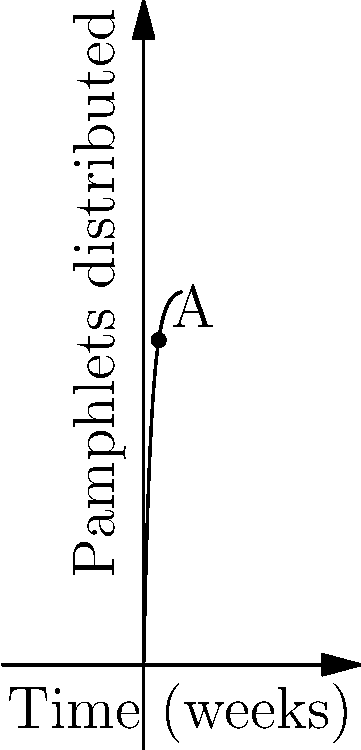The graph shows the cumulative number of pamphlets distributed over time during a political movement. If the distribution follows the function $P(t) = 100(1-e^{-0.5t})$, where $P$ is the number of pamphlets and $t$ is time in weeks, what is the instantaneous rate of pamphlet distribution at point A (4 weeks)? To find the instantaneous rate of pamphlet distribution at point A, we need to follow these steps:

1) The rate of distribution is given by the derivative of the function $P(t)$.

2) Let's find the derivative:
   $\frac{d}{dt}P(t) = \frac{d}{dt}[100(1-e^{-0.5t})]$
   $= 100 \cdot \frac{d}{dt}[-e^{-0.5t}]$
   $= 100 \cdot 0.5e^{-0.5t}$
   $= 50e^{-0.5t}$

3) Now we have the rate function, let's evaluate it at $t=4$:
   Rate at $t=4 = 50e^{-0.5(4)}$
   $= 50e^{-2}$
   $\approx 6.77$ pamphlets per week

Therefore, the instantaneous rate of pamphlet distribution at point A (4 weeks) is approximately 6.77 pamphlets per week.
Answer: $50e^{-2}$ pamphlets/week 